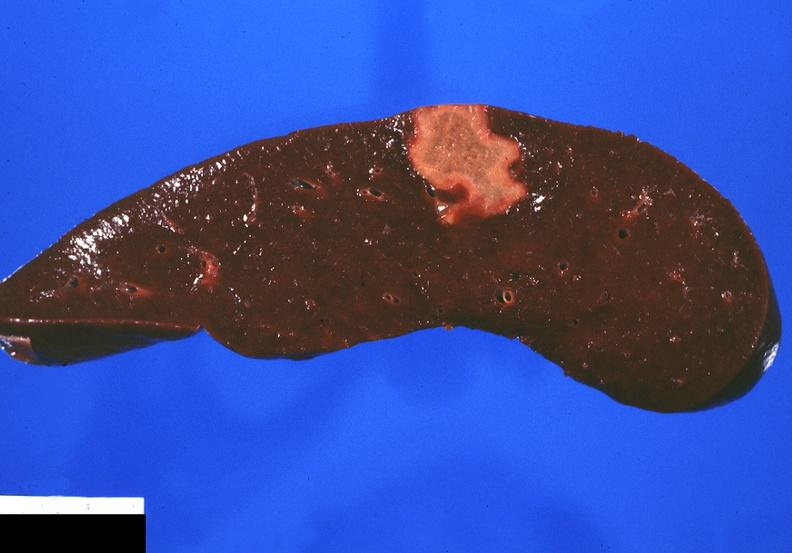does colon show splenic infarct?
Answer the question using a single word or phrase. No 